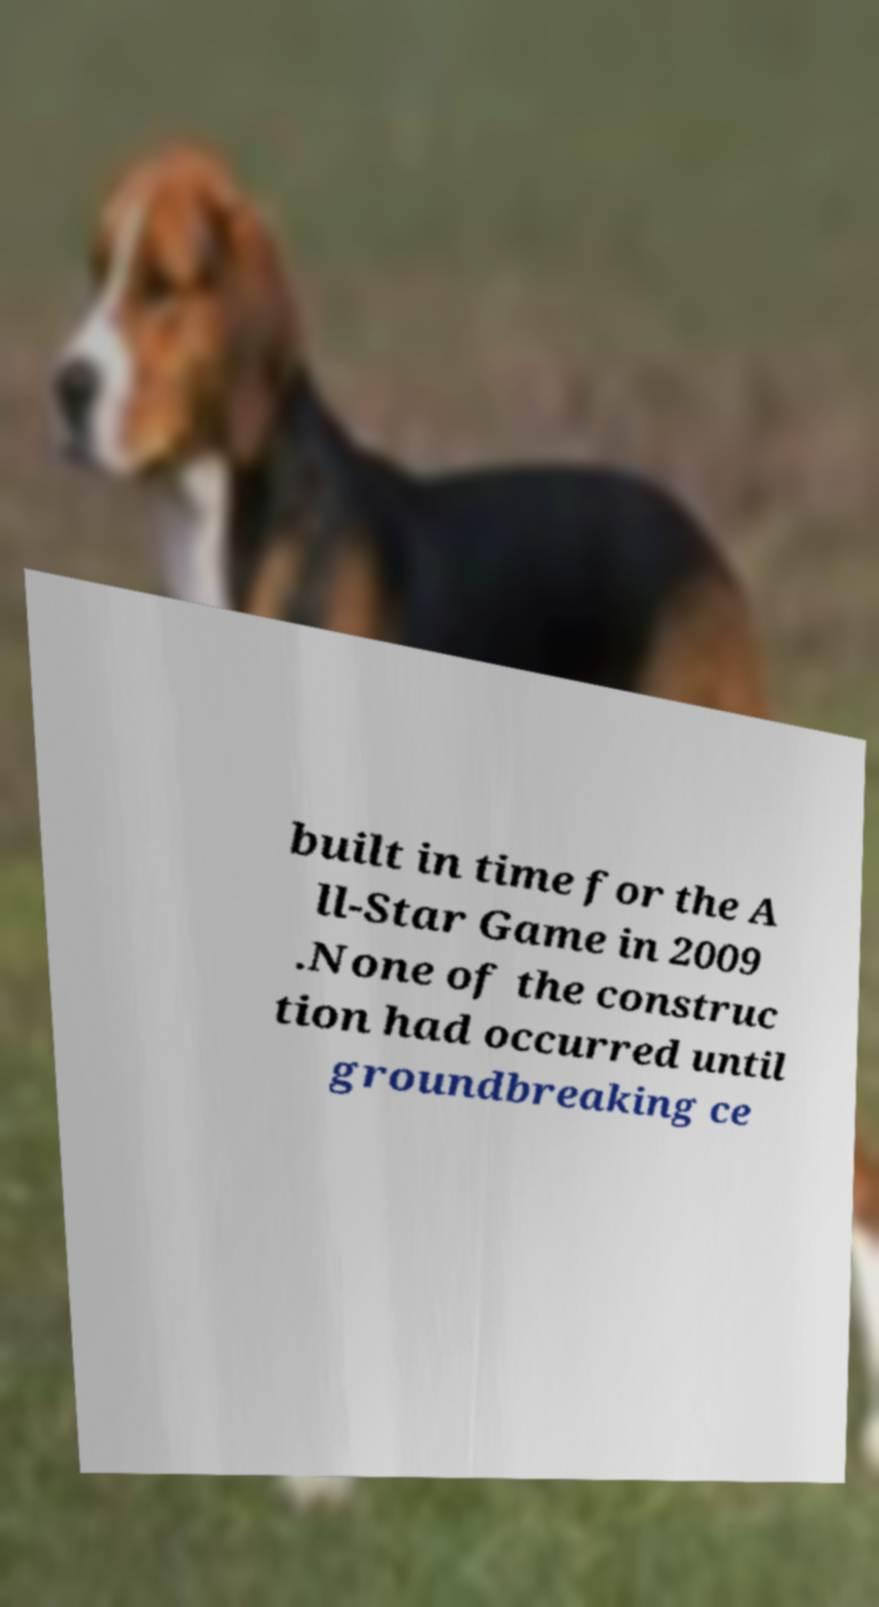Could you assist in decoding the text presented in this image and type it out clearly? built in time for the A ll-Star Game in 2009 .None of the construc tion had occurred until groundbreaking ce 